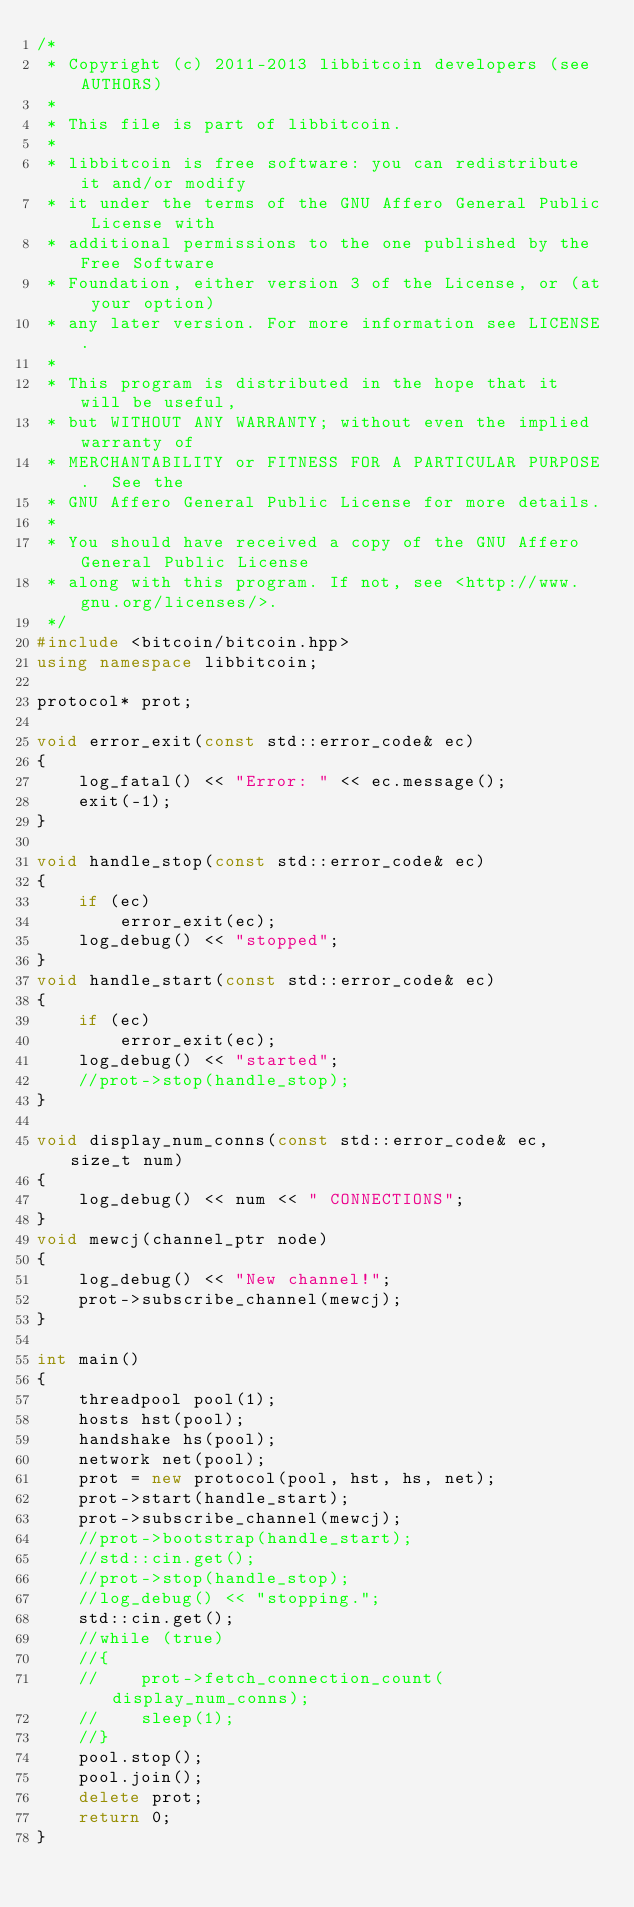<code> <loc_0><loc_0><loc_500><loc_500><_C++_>/*
 * Copyright (c) 2011-2013 libbitcoin developers (see AUTHORS)
 *
 * This file is part of libbitcoin.
 *
 * libbitcoin is free software: you can redistribute it and/or modify
 * it under the terms of the GNU Affero General Public License with
 * additional permissions to the one published by the Free Software
 * Foundation, either version 3 of the License, or (at your option) 
 * any later version. For more information see LICENSE.
 *
 * This program is distributed in the hope that it will be useful,
 * but WITHOUT ANY WARRANTY; without even the implied warranty of
 * MERCHANTABILITY or FITNESS FOR A PARTICULAR PURPOSE.  See the
 * GNU Affero General Public License for more details.
 *
 * You should have received a copy of the GNU Affero General Public License
 * along with this program. If not, see <http://www.gnu.org/licenses/>.
 */
#include <bitcoin/bitcoin.hpp>
using namespace libbitcoin;

protocol* prot;

void error_exit(const std::error_code& ec)
{
    log_fatal() << "Error: " << ec.message();
    exit(-1);
}

void handle_stop(const std::error_code& ec)
{
    if (ec)
        error_exit(ec);
    log_debug() << "stopped";
}
void handle_start(const std::error_code& ec)
{
    if (ec)
        error_exit(ec);
    log_debug() << "started";
    //prot->stop(handle_stop);
}

void display_num_conns(const std::error_code& ec, size_t num)
{
    log_debug() << num << " CONNECTIONS";
}
void mewcj(channel_ptr node)
{
    log_debug() << "New channel!";
    prot->subscribe_channel(mewcj);
}

int main()
{
    threadpool pool(1);
    hosts hst(pool);
    handshake hs(pool);
    network net(pool);
    prot = new protocol(pool, hst, hs, net);
    prot->start(handle_start);
    prot->subscribe_channel(mewcj);
    //prot->bootstrap(handle_start);
    //std::cin.get();
    //prot->stop(handle_stop);
    //log_debug() << "stopping.";
    std::cin.get();
    //while (true)
    //{
    //    prot->fetch_connection_count(display_num_conns);
    //    sleep(1);
    //}
    pool.stop();
    pool.join();
    delete prot;
    return 0;
}

</code> 